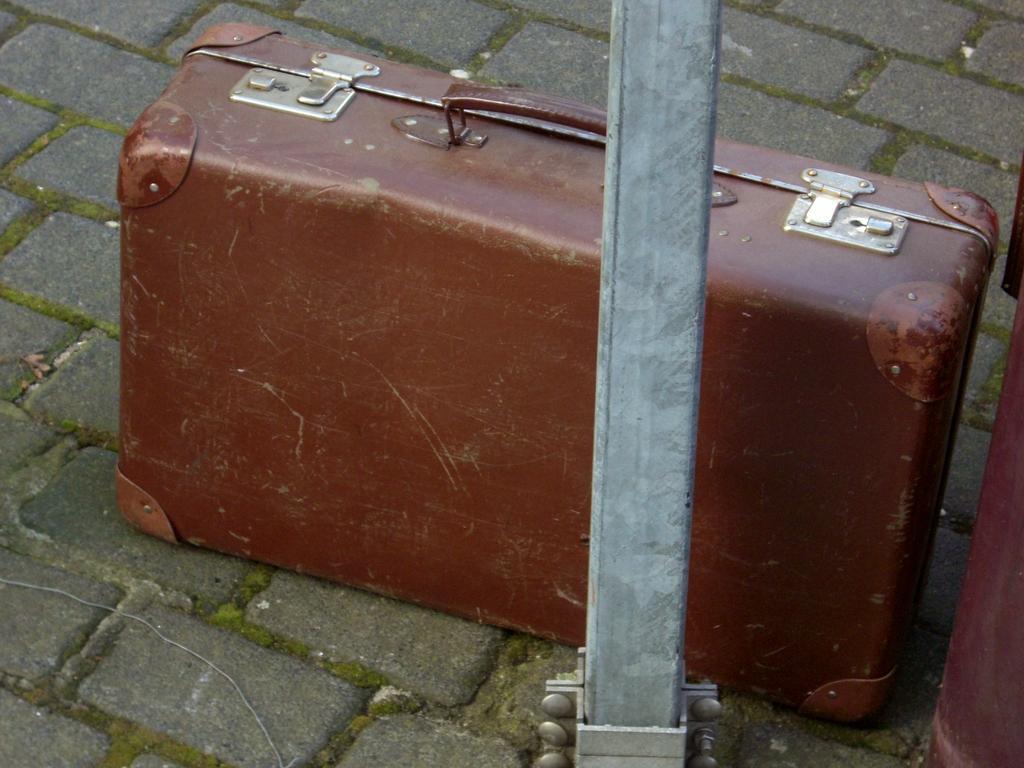Could you give a brief overview of what you see in this image? In this image, we can see box and holder. There is a pillar in this image. And floor we can see. 